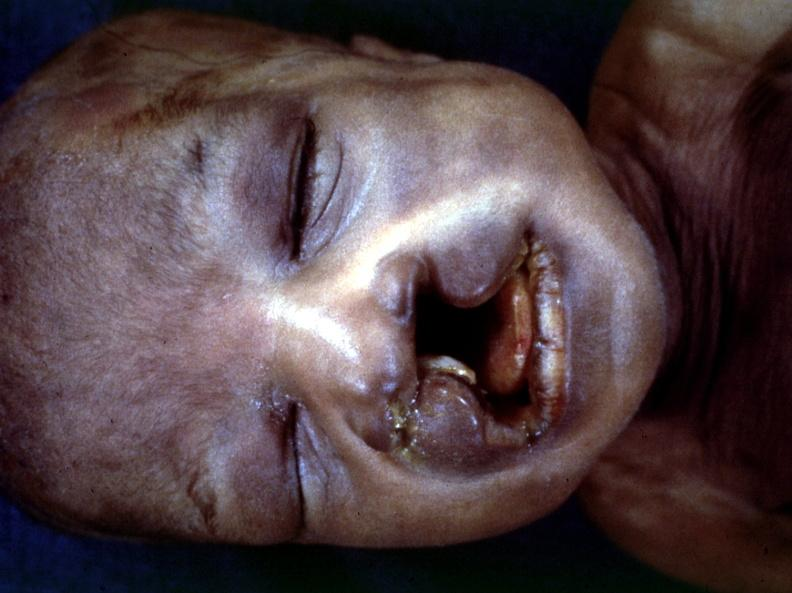what is present?
Answer the question using a single word or phrase. Face 